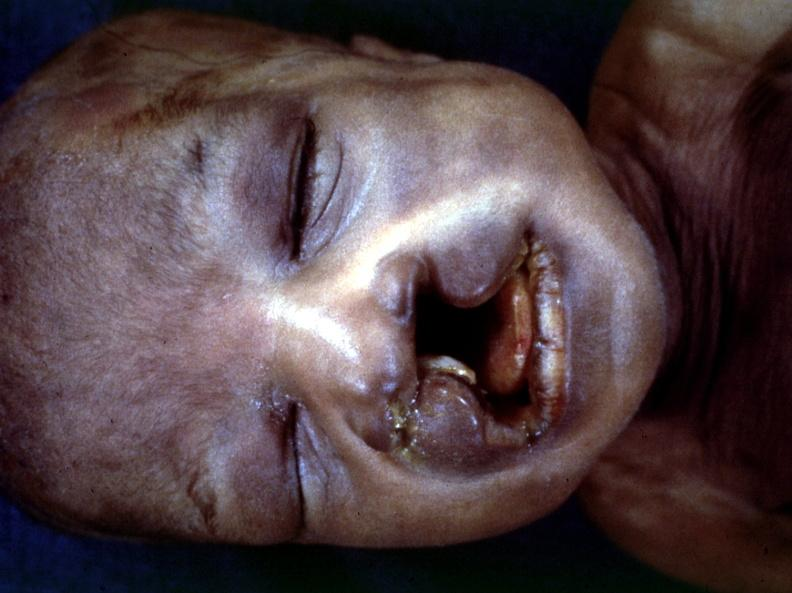what is present?
Answer the question using a single word or phrase. Face 